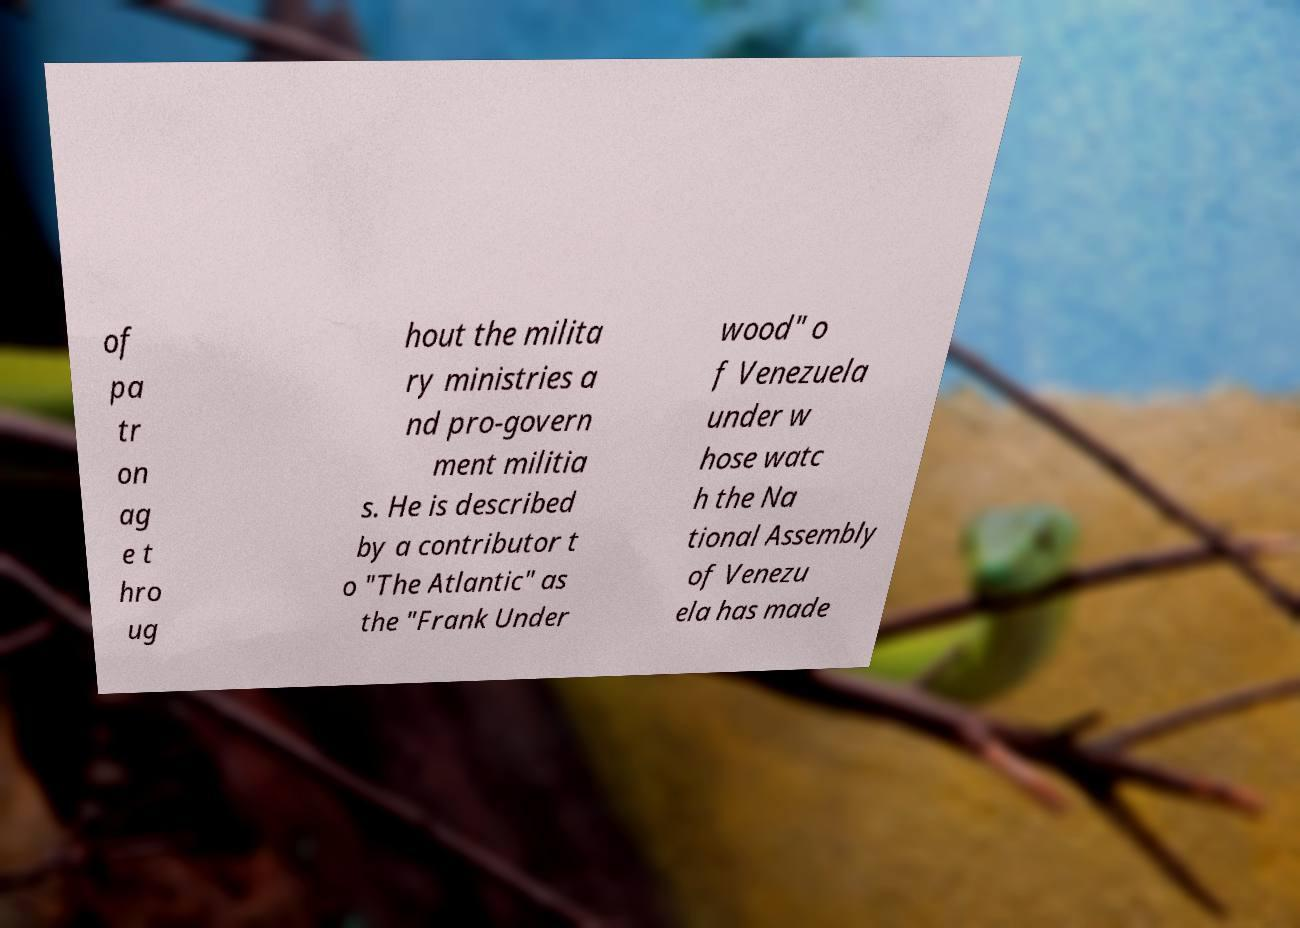I need the written content from this picture converted into text. Can you do that? of pa tr on ag e t hro ug hout the milita ry ministries a nd pro-govern ment militia s. He is described by a contributor t o "The Atlantic" as the "Frank Under wood" o f Venezuela under w hose watc h the Na tional Assembly of Venezu ela has made 